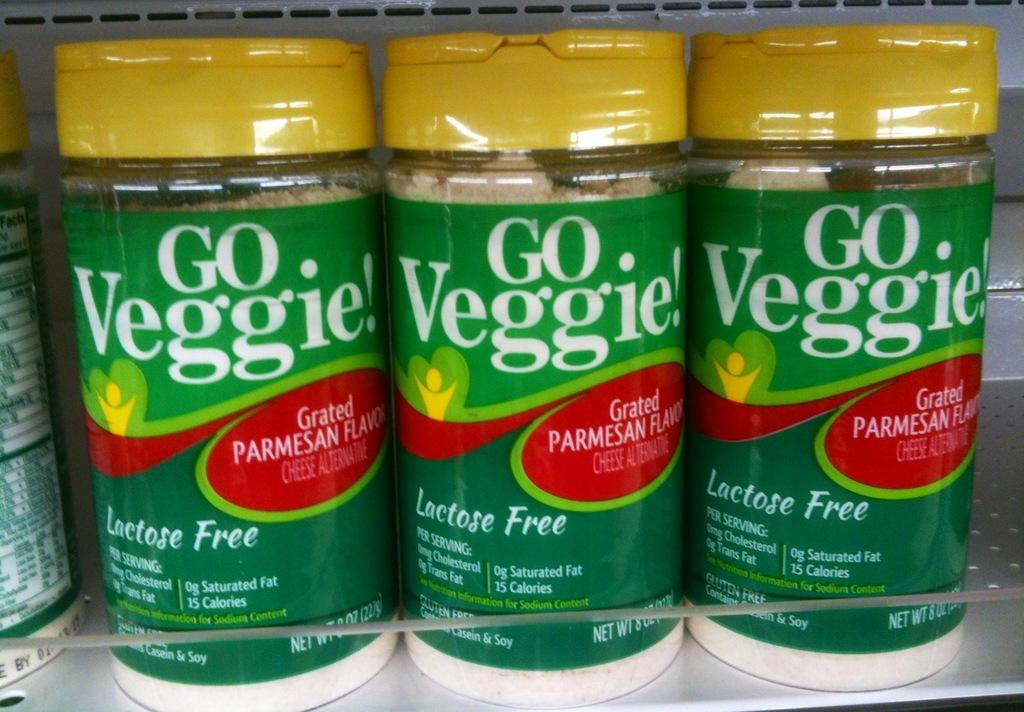<image>
Present a compact description of the photo's key features. A lactose free parmesan cheese made from veggies. 